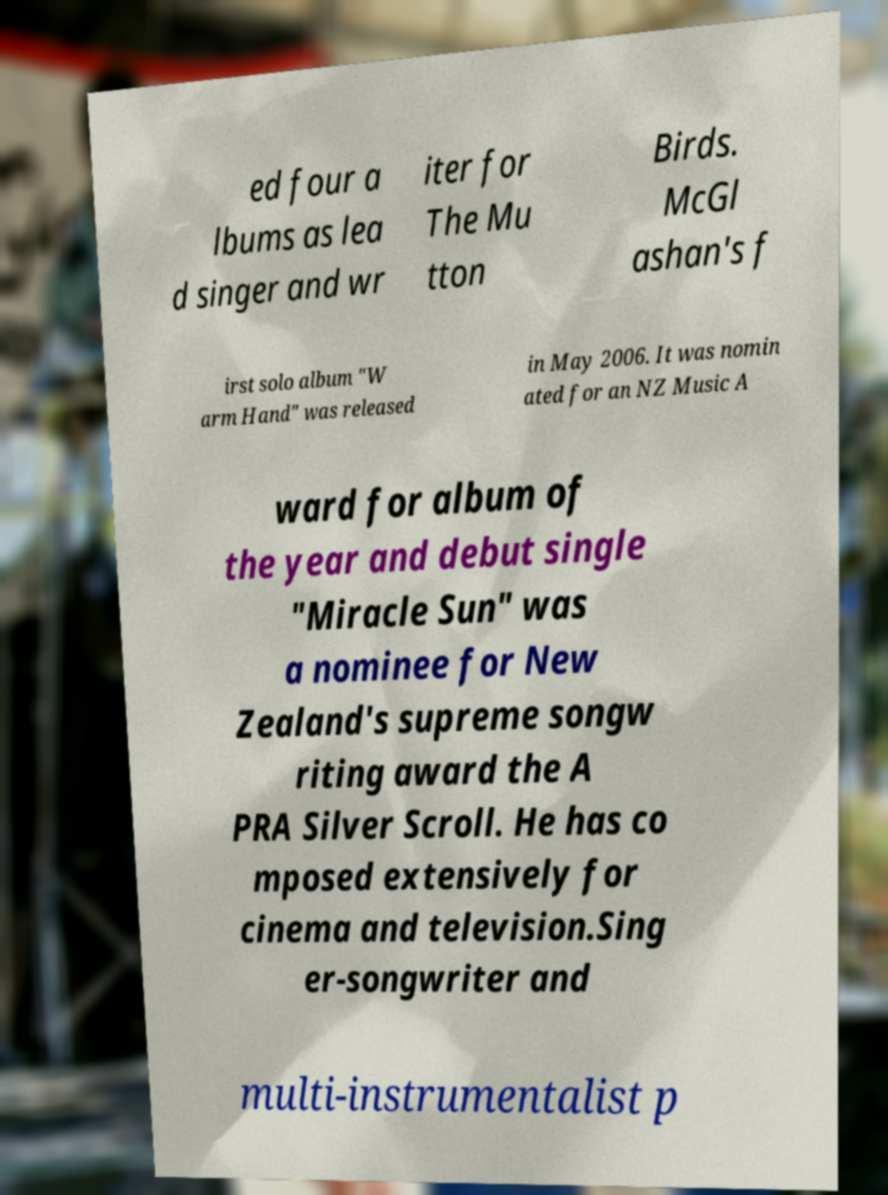Can you read and provide the text displayed in the image?This photo seems to have some interesting text. Can you extract and type it out for me? ed four a lbums as lea d singer and wr iter for The Mu tton Birds. McGl ashan's f irst solo album "W arm Hand" was released in May 2006. It was nomin ated for an NZ Music A ward for album of the year and debut single "Miracle Sun" was a nominee for New Zealand's supreme songw riting award the A PRA Silver Scroll. He has co mposed extensively for cinema and television.Sing er-songwriter and multi-instrumentalist p 